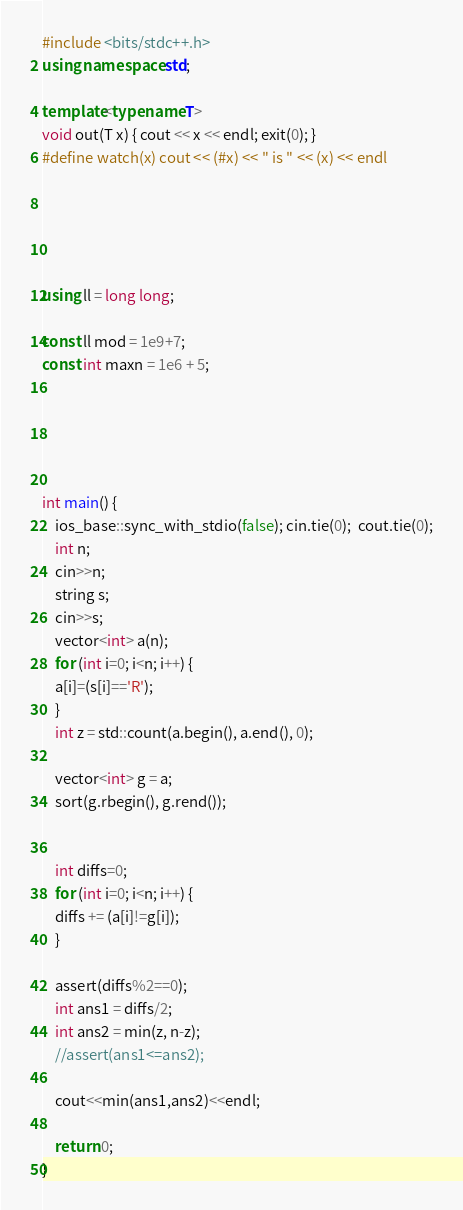<code> <loc_0><loc_0><loc_500><loc_500><_C++_>#include <bits/stdc++.h>
using namespace std;

template<typename T>
void out(T x) { cout << x << endl; exit(0); }
#define watch(x) cout << (#x) << " is " << (x) << endl





using ll = long long;

const ll mod = 1e9+7;
const int maxn = 1e6 + 5;





int main() {
    ios_base::sync_with_stdio(false); cin.tie(0);  cout.tie(0);
    int n;
    cin>>n;
    string s;
    cin>>s;
    vector<int> a(n);
    for (int i=0; i<n; i++) {
	a[i]=(s[i]=='R');
    }
    int z = std::count(a.begin(), a.end(), 0);
    
    vector<int> g = a;
    sort(g.rbegin(), g.rend());

    
    int diffs=0;
    for (int i=0; i<n; i++) {
	diffs += (a[i]!=g[i]);
    }

    assert(diffs%2==0);
    int ans1 = diffs/2;
    int ans2 = min(z, n-z);
    //assert(ans1<=ans2);

    cout<<min(ans1,ans2)<<endl;    
    
    return 0;
}
</code> 